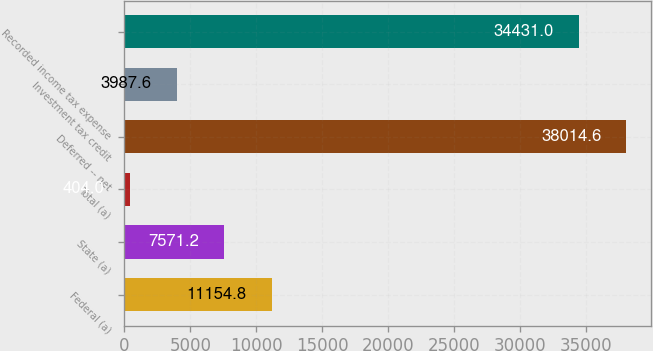<chart> <loc_0><loc_0><loc_500><loc_500><bar_chart><fcel>Federal (a)<fcel>State (a)<fcel>Total (a)<fcel>Deferred -- net<fcel>Investment tax credit<fcel>Recorded income tax expense<nl><fcel>11154.8<fcel>7571.2<fcel>404<fcel>38014.6<fcel>3987.6<fcel>34431<nl></chart> 